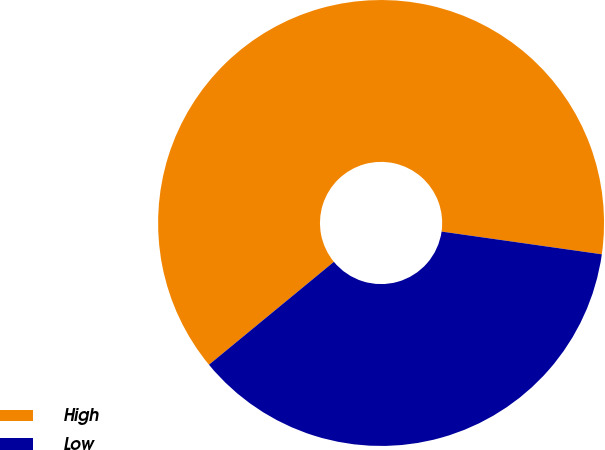Convert chart to OTSL. <chart><loc_0><loc_0><loc_500><loc_500><pie_chart><fcel>High<fcel>Low<nl><fcel>63.21%<fcel>36.79%<nl></chart> 